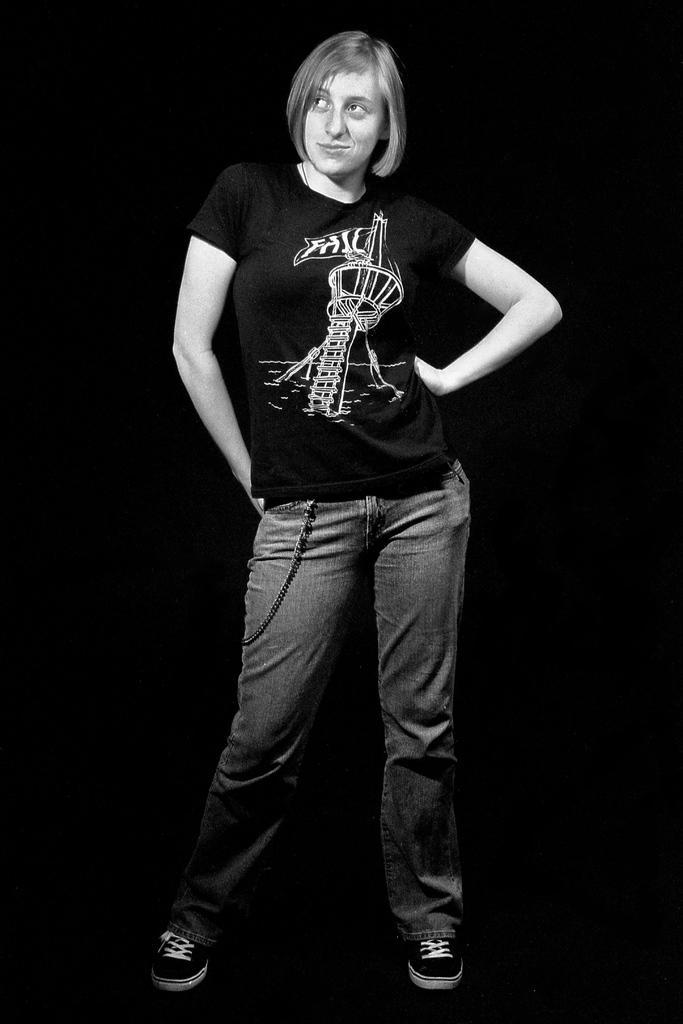In one or two sentences, can you explain what this image depicts? In this image we can see a person wearing black color T-shirt, jeans and shoes standing. 